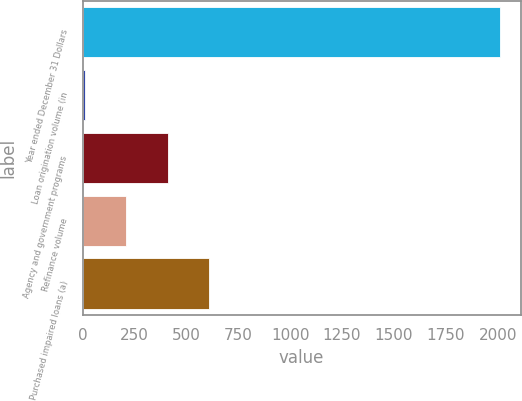Convert chart. <chart><loc_0><loc_0><loc_500><loc_500><bar_chart><fcel>Year ended December 31 Dollars<fcel>Loan origination volume (in<fcel>Agency and government programs<fcel>Refinance volume<fcel>Purchased impaired loans (a)<nl><fcel>2010<fcel>10.5<fcel>410.4<fcel>210.45<fcel>610.35<nl></chart> 